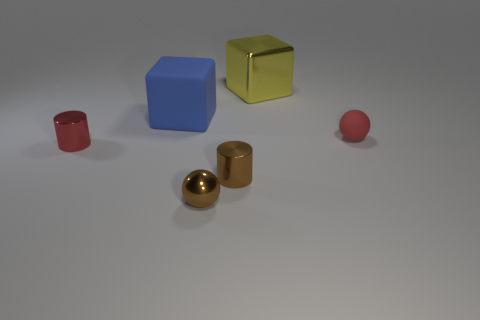Subtract all cyan blocks. Subtract all red cylinders. How many blocks are left? 2 Add 3 metal blocks. How many objects exist? 9 Subtract all cylinders. How many objects are left? 4 Add 6 big cyan rubber cylinders. How many big cyan rubber cylinders exist? 6 Subtract 1 red cylinders. How many objects are left? 5 Subtract all cubes. Subtract all blue matte things. How many objects are left? 3 Add 6 tiny brown balls. How many tiny brown balls are left? 7 